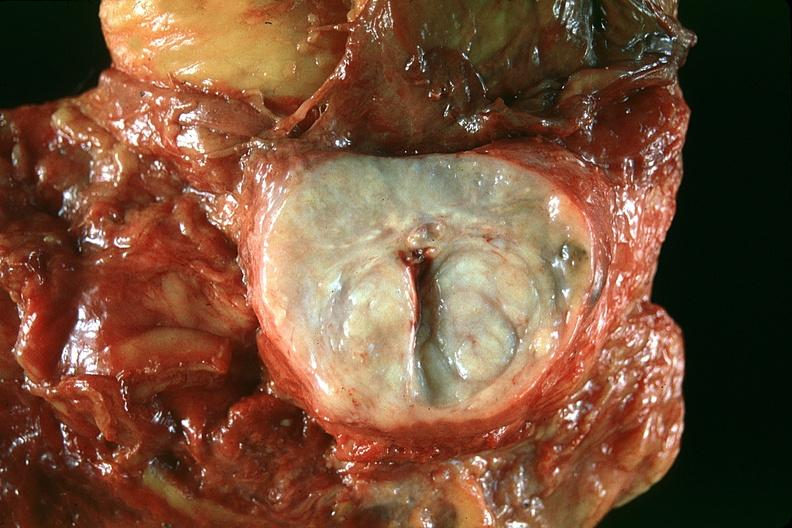what is present?
Answer the question using a single word or phrase. Urinary 